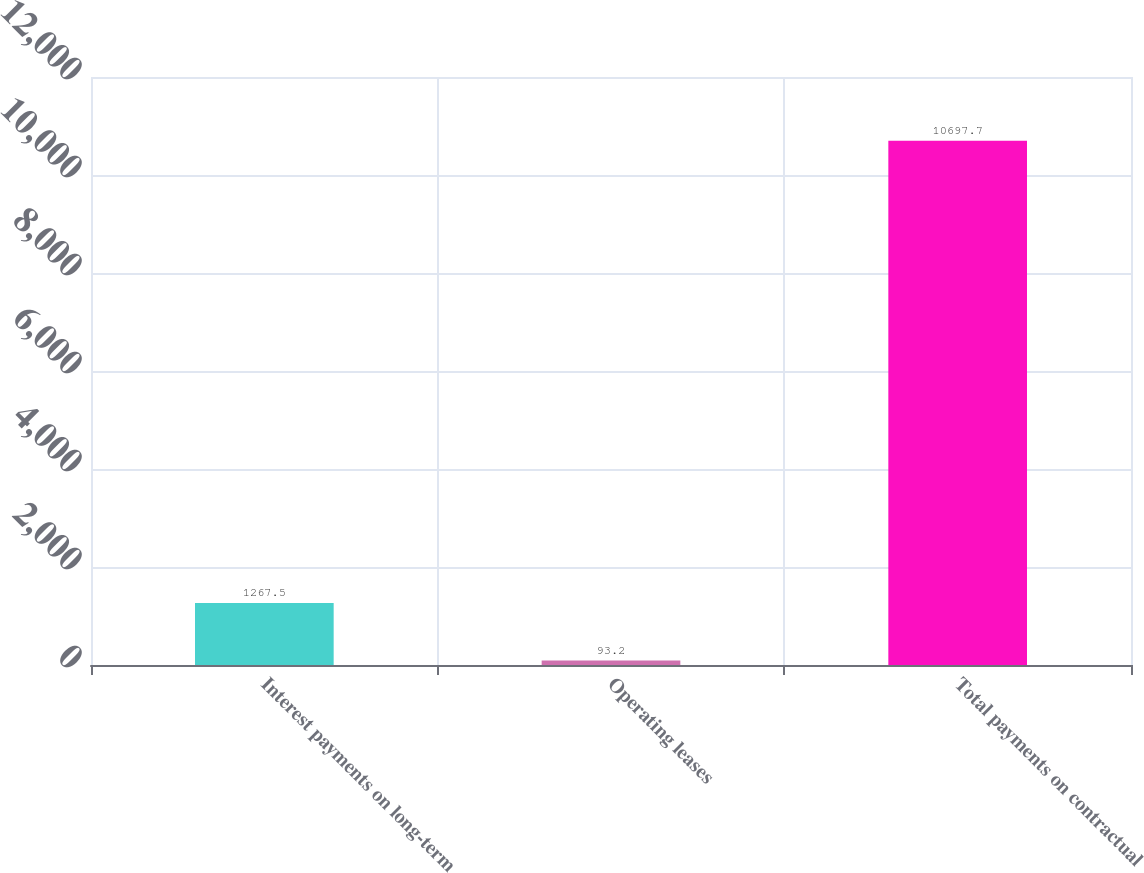Convert chart. <chart><loc_0><loc_0><loc_500><loc_500><bar_chart><fcel>Interest payments on long-term<fcel>Operating leases<fcel>Total payments on contractual<nl><fcel>1267.5<fcel>93.2<fcel>10697.7<nl></chart> 